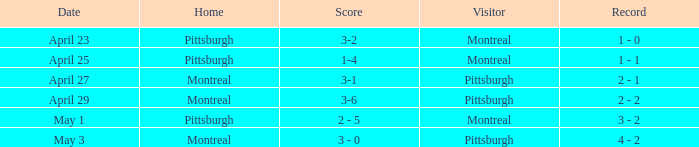What was the score on May 3? 3 - 0. 